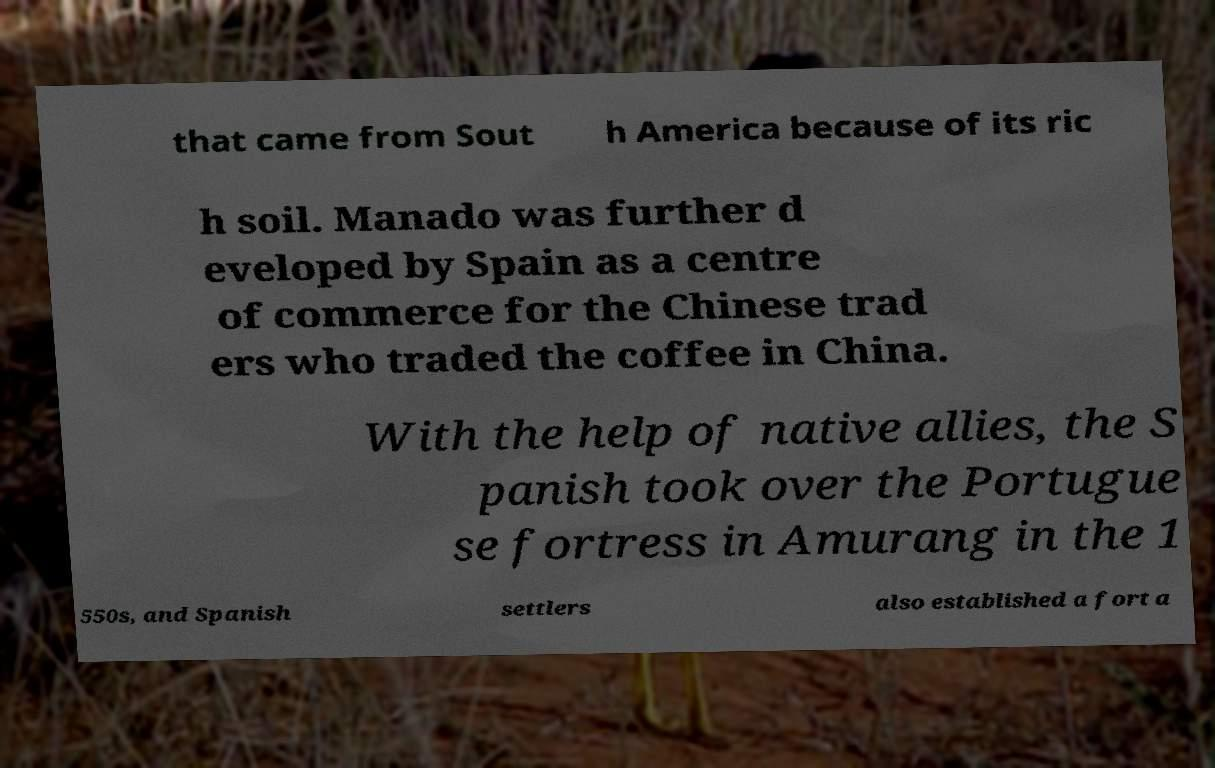Can you read and provide the text displayed in the image?This photo seems to have some interesting text. Can you extract and type it out for me? that came from Sout h America because of its ric h soil. Manado was further d eveloped by Spain as a centre of commerce for the Chinese trad ers who traded the coffee in China. With the help of native allies, the S panish took over the Portugue se fortress in Amurang in the 1 550s, and Spanish settlers also established a fort a 